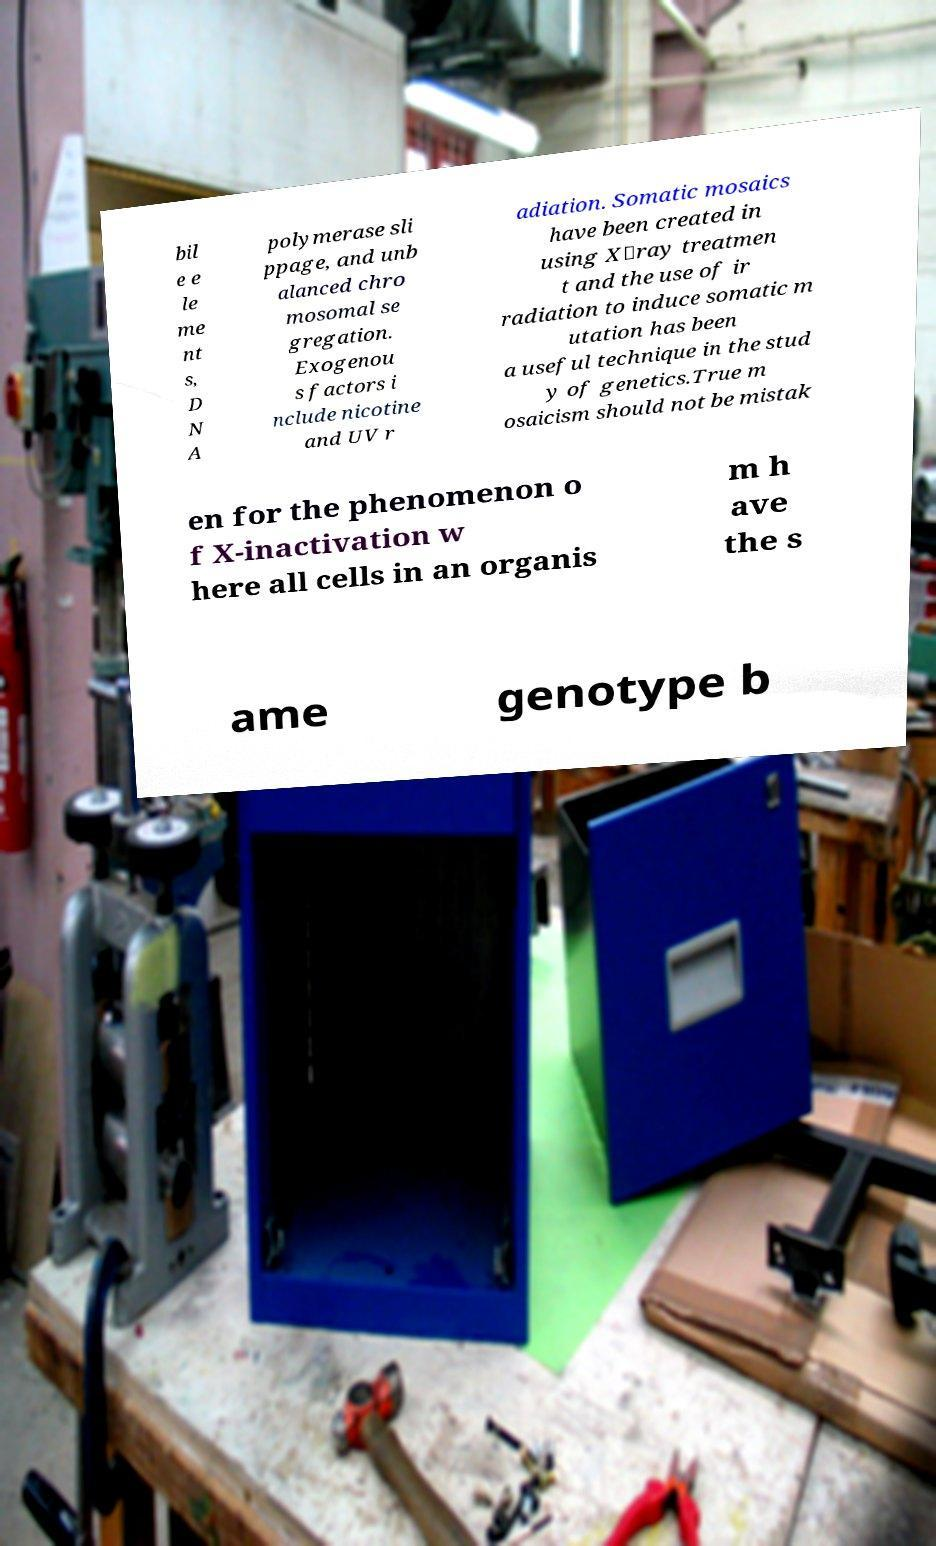Could you assist in decoding the text presented in this image and type it out clearly? bil e e le me nt s, D N A polymerase sli ppage, and unb alanced chro mosomal se gregation. Exogenou s factors i nclude nicotine and UV r adiation. Somatic mosaics have been created in using X‑ray treatmen t and the use of ir radiation to induce somatic m utation has been a useful technique in the stud y of genetics.True m osaicism should not be mistak en for the phenomenon o f X-inactivation w here all cells in an organis m h ave the s ame genotype b 